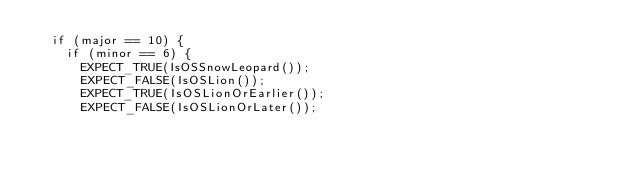Convert code to text. <code><loc_0><loc_0><loc_500><loc_500><_ObjectiveC_>  if (major == 10) {
    if (minor == 6) {
      EXPECT_TRUE(IsOSSnowLeopard());
      EXPECT_FALSE(IsOSLion());
      EXPECT_TRUE(IsOSLionOrEarlier());
      EXPECT_FALSE(IsOSLionOrLater());</code> 